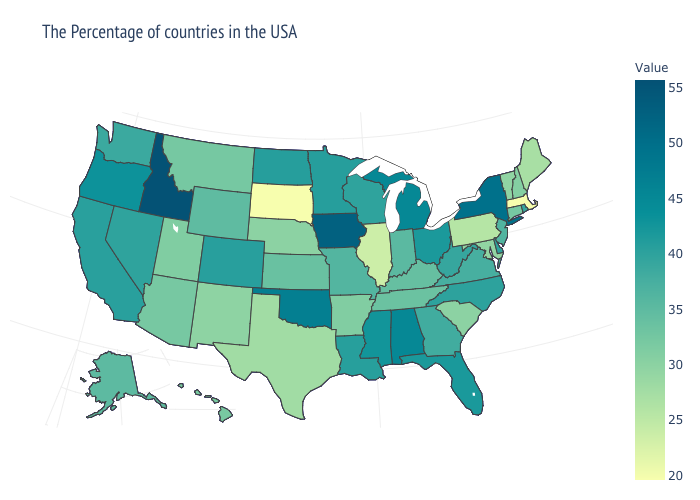Which states have the lowest value in the West?
Give a very brief answer. New Mexico. Does Mississippi have a lower value than Kentucky?
Keep it brief. No. Which states have the highest value in the USA?
Give a very brief answer. Idaho. Is the legend a continuous bar?
Give a very brief answer. Yes. 